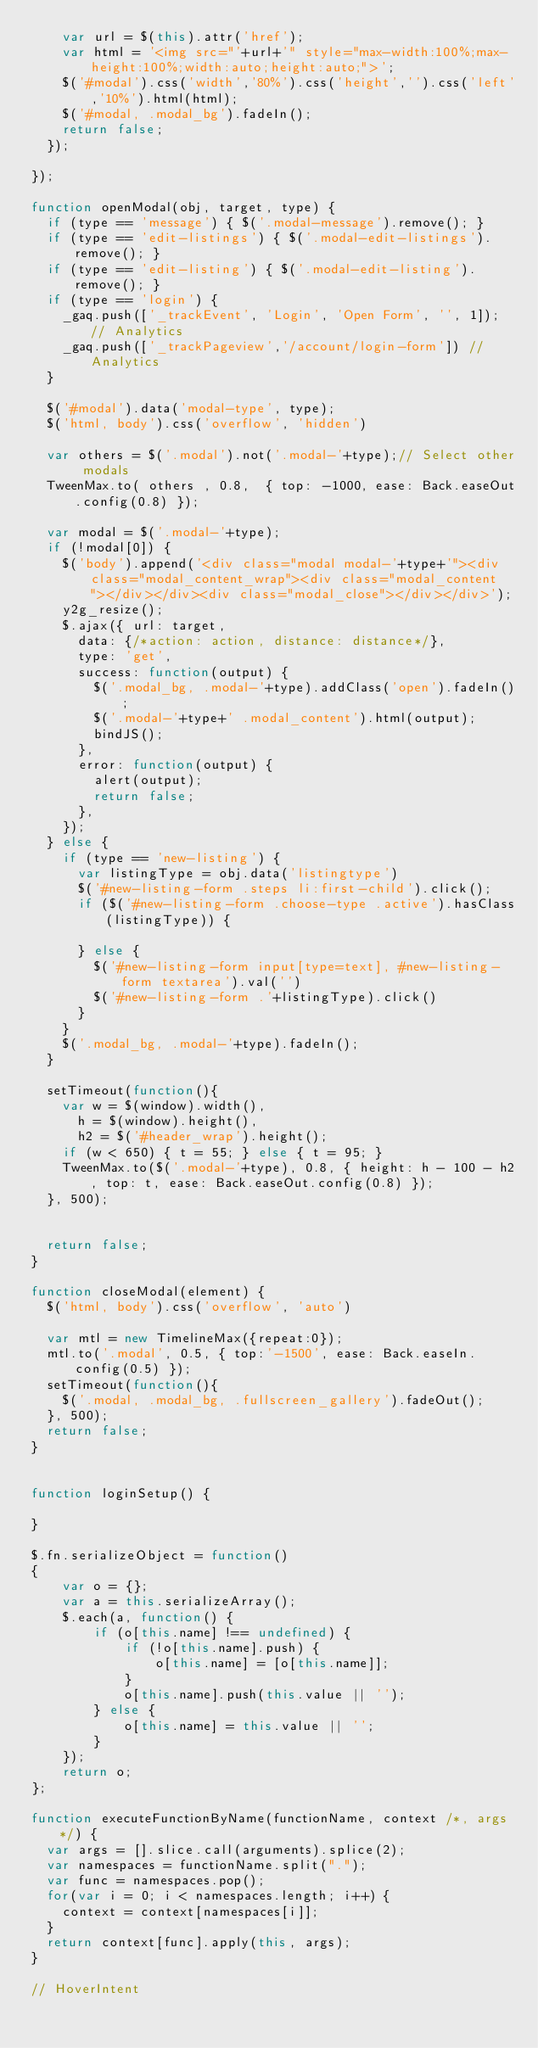<code> <loc_0><loc_0><loc_500><loc_500><_JavaScript_>		var url = $(this).attr('href');
		var html = '<img src="'+url+'" style="max-width:100%;max-height:100%;width:auto;height:auto;">';
		$('#modal').css('width','80%').css('height','').css('left','10%').html(html);
		$('#modal, .modal_bg').fadeIn();
		return false;
	});

});

function openModal(obj, target, type) {
	if (type == 'message') { $('.modal-message').remove(); }
	if (type == 'edit-listings') { $('.modal-edit-listings').remove(); }
	if (type == 'edit-listing') { $('.modal-edit-listing').remove(); }
	if (type == 'login') {
		_gaq.push(['_trackEvent', 'Login', 'Open Form', '', 1]); // Analytics
		_gaq.push(['_trackPageview','/account/login-form']) // Analytics
	}

	$('#modal').data('modal-type', type);
	$('html, body').css('overflow', 'hidden')

	var others = $('.modal').not('.modal-'+type);// Select other modals
	TweenMax.to( others , 0.8,  { top: -1000, ease: Back.easeOut.config(0.8) });

	var modal = $('.modal-'+type);
	if (!modal[0]) {
		$('body').append('<div class="modal modal-'+type+'"><div class="modal_content_wrap"><div class="modal_content"></div></div><div class="modal_close"></div></div>');
		y2g_resize();
		$.ajax({ url: target,
			data: {/*action: action, distance: distance*/},
			type: 'get',
			success: function(output) {
				$('.modal_bg, .modal-'+type).addClass('open').fadeIn();
				$('.modal-'+type+' .modal_content').html(output);
				bindJS();
			},
			error: function(output) {
				alert(output);
				return false;
			},
		});
	} else {
		if (type == 'new-listing') {
			var listingType = obj.data('listingtype')
			$('#new-listing-form .steps li:first-child').click();
			if ($('#new-listing-form .choose-type .active').hasClass(listingType)) {

			} else {
				$('#new-listing-form input[type=text], #new-listing-form textarea').val('')
				$('#new-listing-form .'+listingType).click()
			}
		}
		$('.modal_bg, .modal-'+type).fadeIn();
	}

	setTimeout(function(){
		var w = $(window).width(),
			h = $(window).height(),
			h2 = $('#header_wrap').height();
		if (w < 650) { t = 55; } else { t = 95; }
    TweenMax.to($('.modal-'+type), 0.8, { height: h - 100 - h2, top: t, ease: Back.easeOut.config(0.8) });
	}, 500);


	return false;
}

function closeModal(element) {
	$('html, body').css('overflow', 'auto')

	var mtl = new TimelineMax({repeat:0});
	mtl.to('.modal', 0.5, { top:'-1500', ease: Back.easeIn.config(0.5) });
	setTimeout(function(){
		$('.modal, .modal_bg, .fullscreen_gallery').fadeOut();
	}, 500);
	return false;
}


function loginSetup() {

}

$.fn.serializeObject = function()
{
    var o = {};
    var a = this.serializeArray();
    $.each(a, function() {
        if (o[this.name] !== undefined) {
            if (!o[this.name].push) {
                o[this.name] = [o[this.name]];
            }
            o[this.name].push(this.value || '');
        } else {
            o[this.name] = this.value || '';
        }
    });
    return o;
};

function executeFunctionByName(functionName, context /*, args */) {
  var args = [].slice.call(arguments).splice(2);
  var namespaces = functionName.split(".");
  var func = namespaces.pop();
  for(var i = 0; i < namespaces.length; i++) {
    context = context[namespaces[i]];
  }
  return context[func].apply(this, args);
}

// HoverIntent</code> 